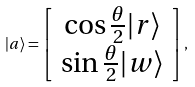Convert formula to latex. <formula><loc_0><loc_0><loc_500><loc_500>| a \rangle = \left [ \begin{array} { c } \cos \frac { \theta } { 2 } | r \rangle \\ \sin \frac { \theta } { 2 } | w \rangle \end{array} \right ] ,</formula> 